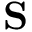Convert formula to latex. <formula><loc_0><loc_0><loc_500><loc_500>S</formula> 